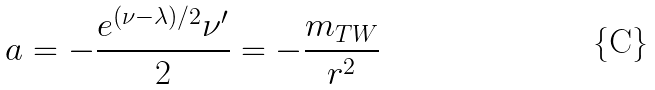<formula> <loc_0><loc_0><loc_500><loc_500>a = - \frac { e ^ { ( \nu - \lambda ) / 2 } \nu ^ { \prime } } { 2 } = - \frac { m _ { T W } } { r ^ { 2 } }</formula> 